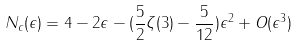<formula> <loc_0><loc_0><loc_500><loc_500>N _ { c } ( \epsilon ) = 4 - 2 \epsilon - ( \frac { 5 } { 2 } \zeta ( 3 ) - \frac { 5 } { 1 2 } ) \epsilon ^ { 2 } + O ( \epsilon ^ { 3 } )</formula> 